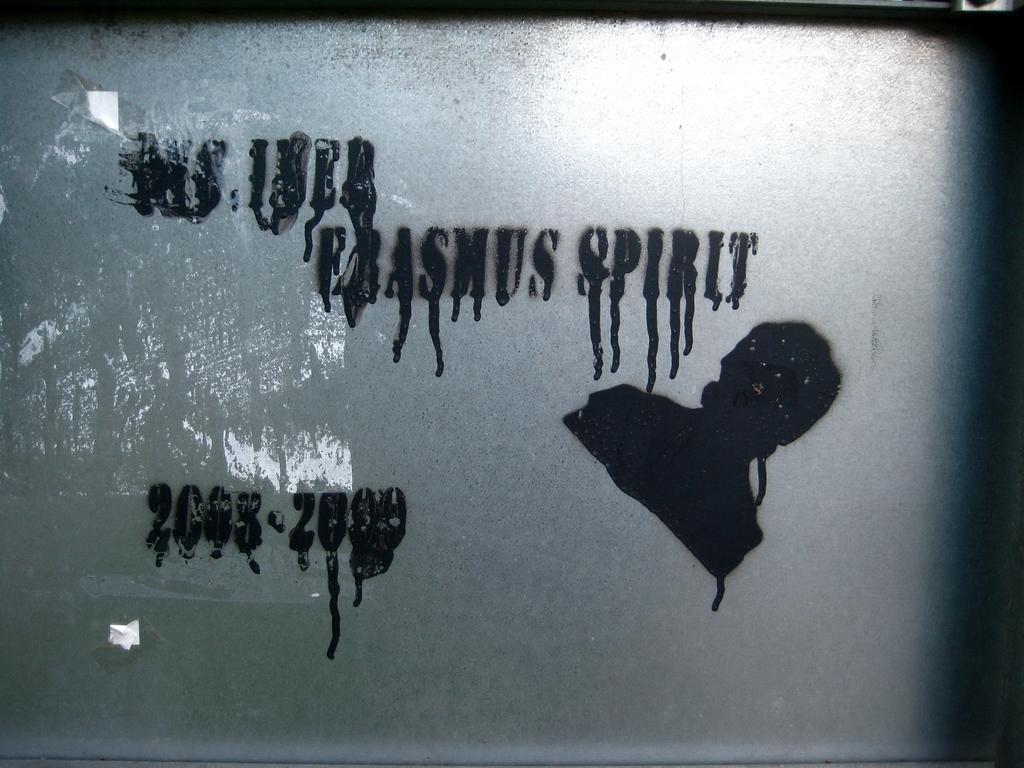What can be found in the image that contains written information? There is text in the image. What is shown in the image besides the text? There is a depiction of a person in the image. What type of lamp is being used by the person in the image? There is no lamp present in the image; it only contains text and a depiction of a person. How many ears does the person in the image have? The provided facts do not mention the number of ears the person in the image has, so we cannot definitively answer this question. 